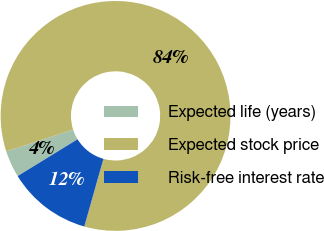Convert chart to OTSL. <chart><loc_0><loc_0><loc_500><loc_500><pie_chart><fcel>Expected life (years)<fcel>Expected stock price<fcel>Risk-free interest rate<nl><fcel>3.78%<fcel>84.38%<fcel>11.84%<nl></chart> 